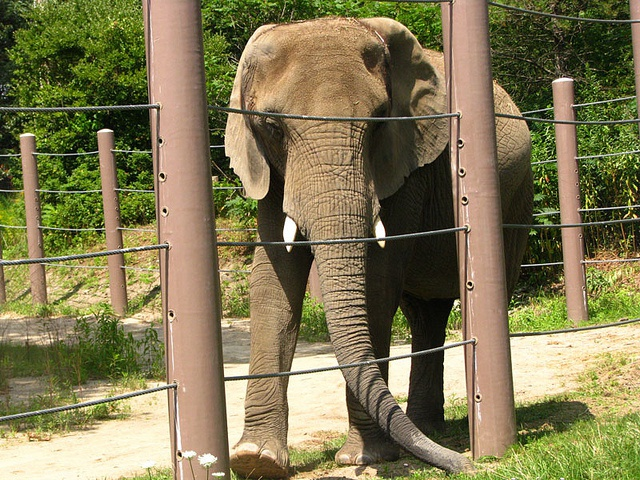Describe the objects in this image and their specific colors. I can see a elephant in darkgreen, black, tan, and gray tones in this image. 